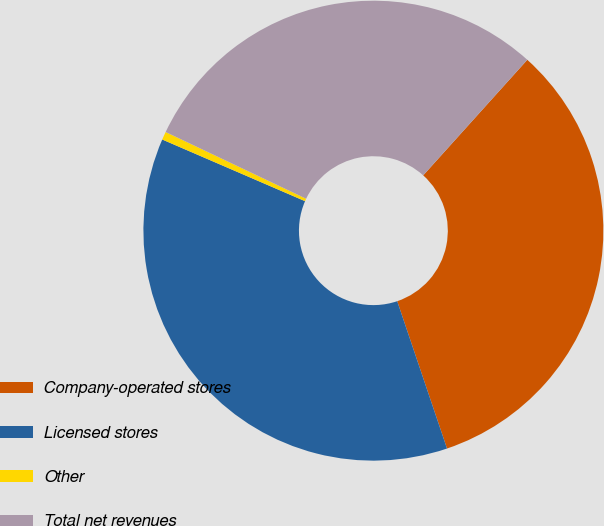Convert chart. <chart><loc_0><loc_0><loc_500><loc_500><pie_chart><fcel>Company-operated stores<fcel>Licensed stores<fcel>Other<fcel>Total net revenues<nl><fcel>33.14%<fcel>36.67%<fcel>0.57%<fcel>29.61%<nl></chart> 